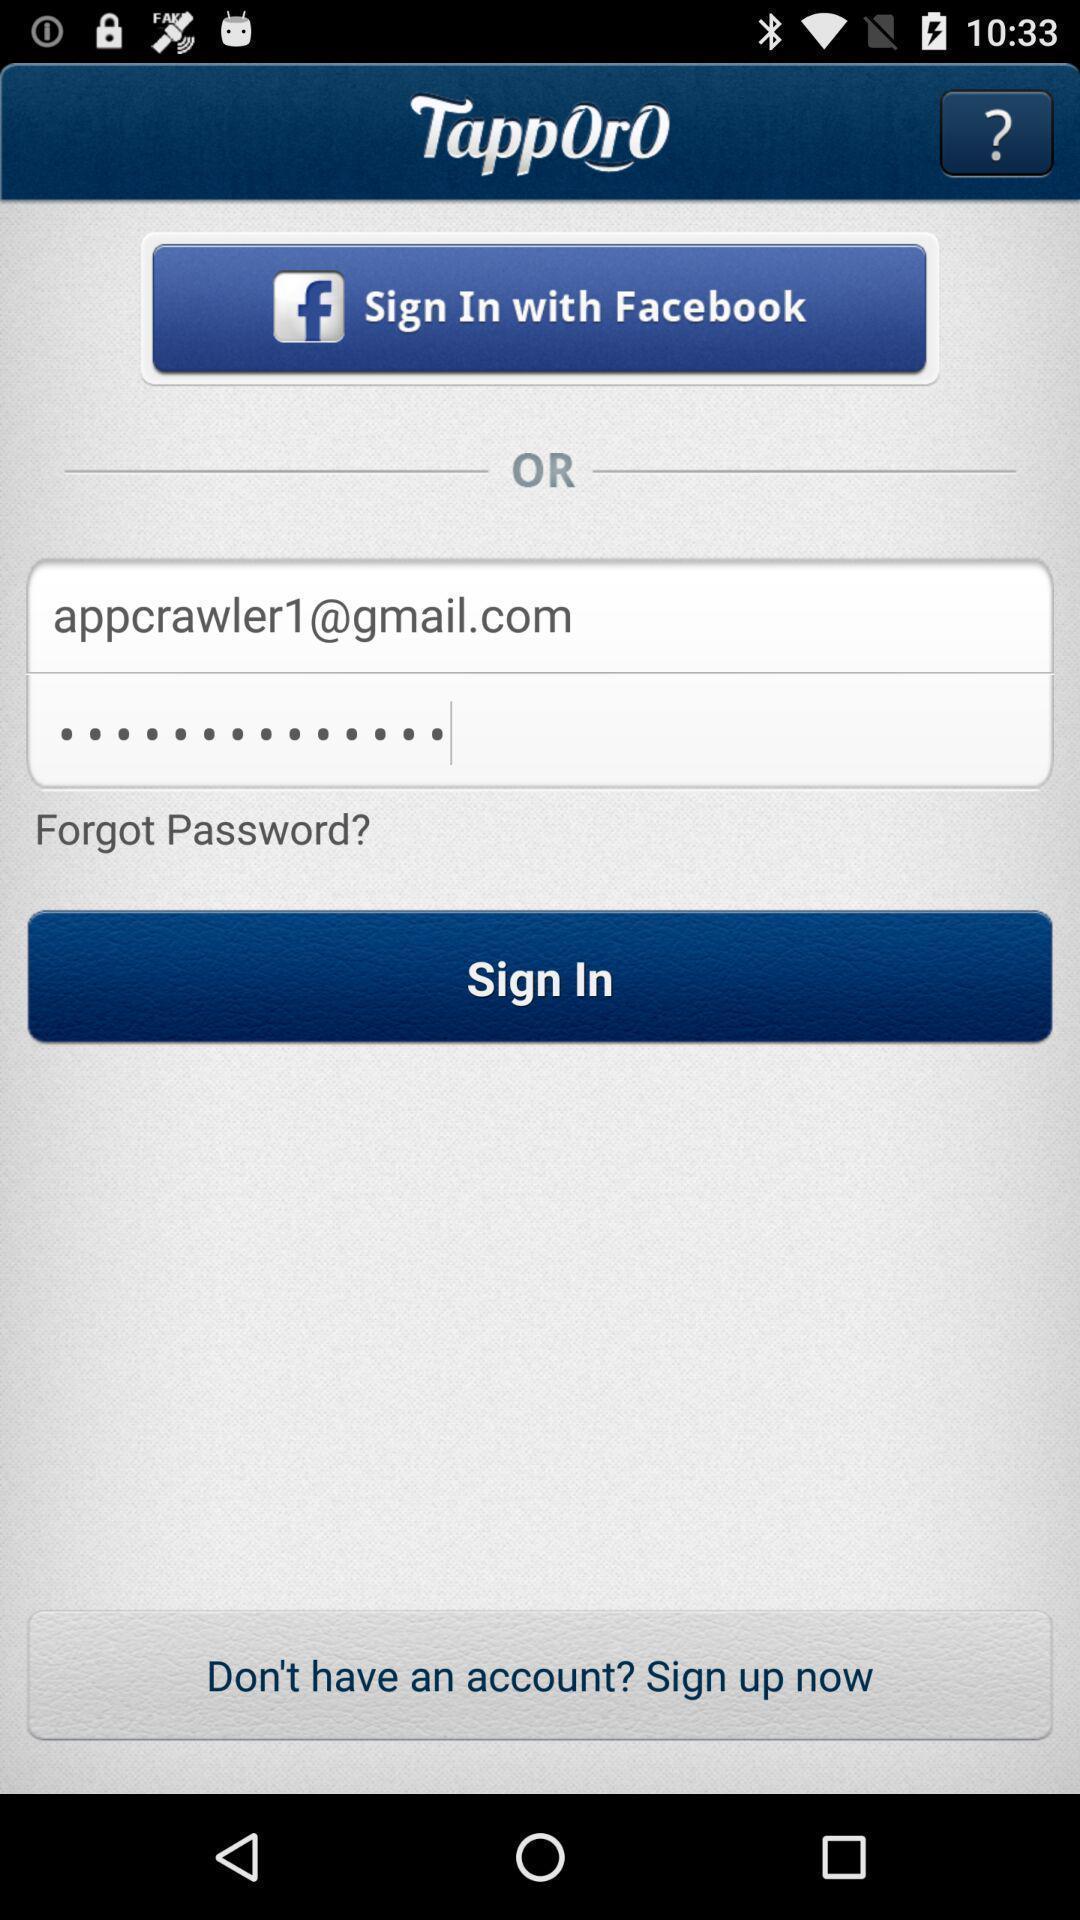Tell me what you see in this picture. Welcome page showing different option to login. 